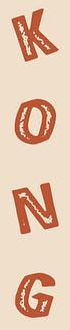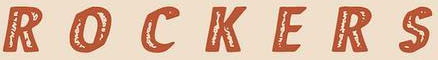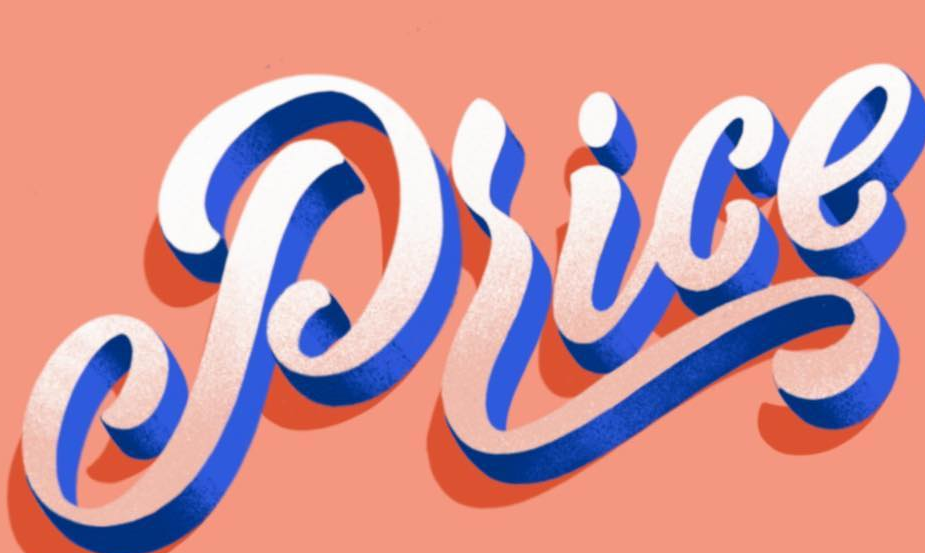Transcribe the words shown in these images in order, separated by a semicolon. KONG; ROCKERS; Price 